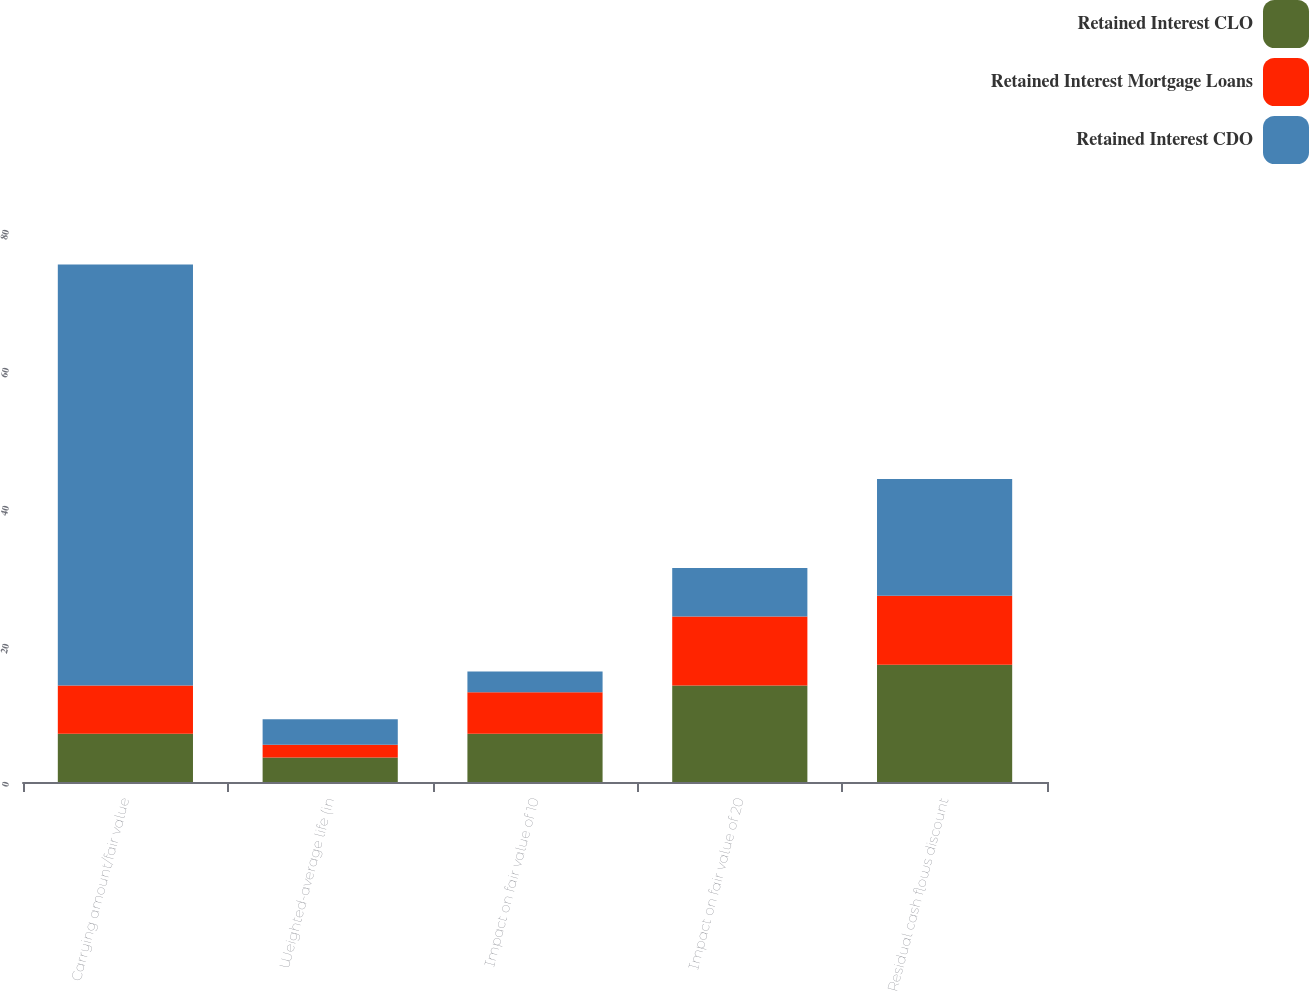Convert chart. <chart><loc_0><loc_0><loc_500><loc_500><stacked_bar_chart><ecel><fcel>Carrying amount/fair value<fcel>Weighted-average life (in<fcel>Impact on fair value of 10<fcel>Impact on fair value of 20<fcel>Residual cash flows discount<nl><fcel>Retained Interest CLO<fcel>7<fcel>3.54<fcel>7<fcel>14<fcel>17<nl><fcel>Retained Interest Mortgage Loans<fcel>7<fcel>1.87<fcel>6<fcel>10<fcel>10<nl><fcel>Retained Interest CDO<fcel>61<fcel>3.69<fcel>3<fcel>7<fcel>16.9<nl></chart> 